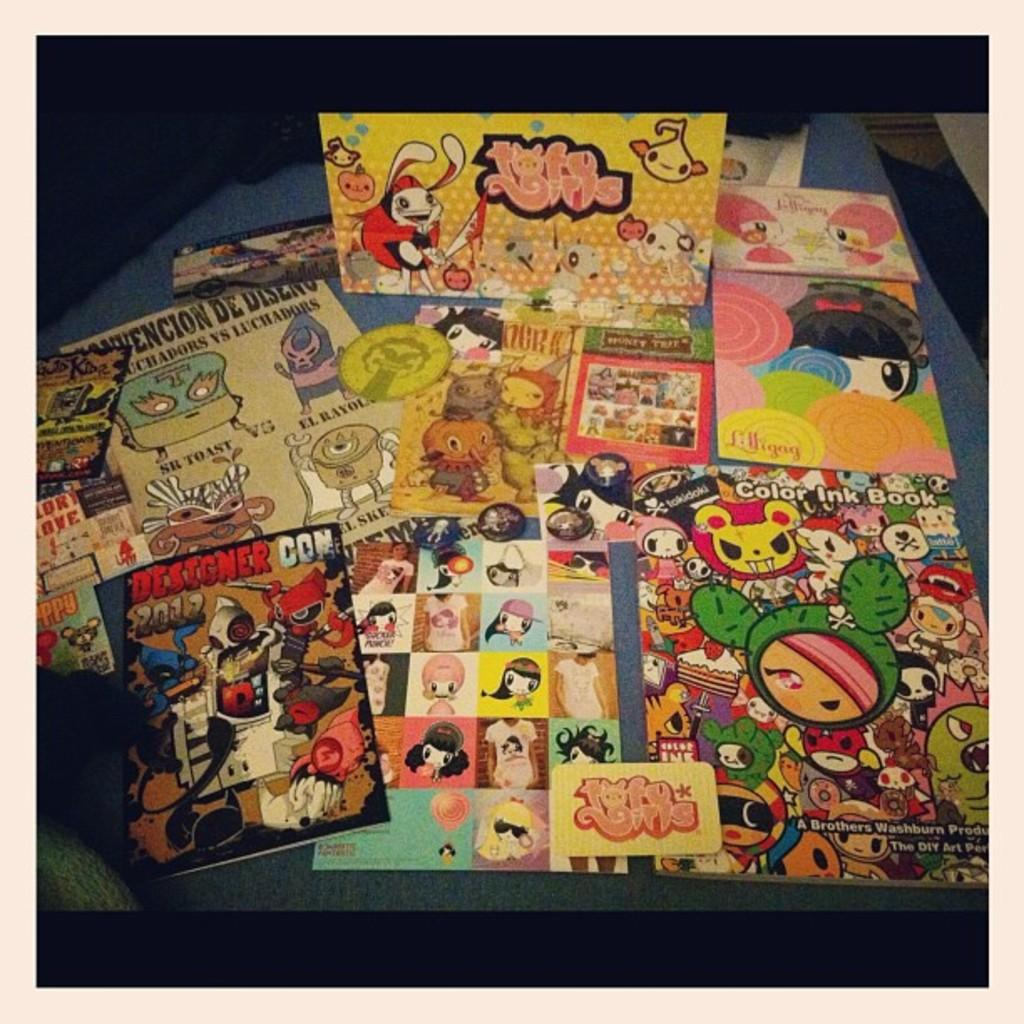<image>
Describe the image concisely. A booklet titled Designer Con lays on a clutter table. 